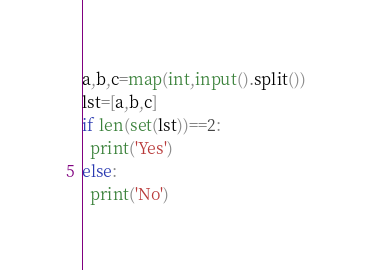<code> <loc_0><loc_0><loc_500><loc_500><_Python_>a,b,c=map(int,input().split())
lst=[a,b,c]
if len(set(lst))==2:
  print('Yes')
else:
  print('No')</code> 